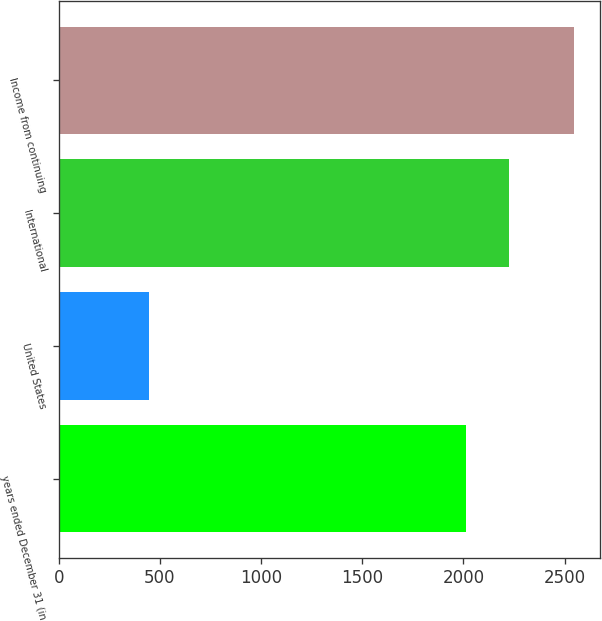Convert chart to OTSL. <chart><loc_0><loc_0><loc_500><loc_500><bar_chart><fcel>years ended December 31 (in<fcel>United States<fcel>International<fcel>Income from continuing<nl><fcel>2013<fcel>446<fcel>2223<fcel>2546<nl></chart> 